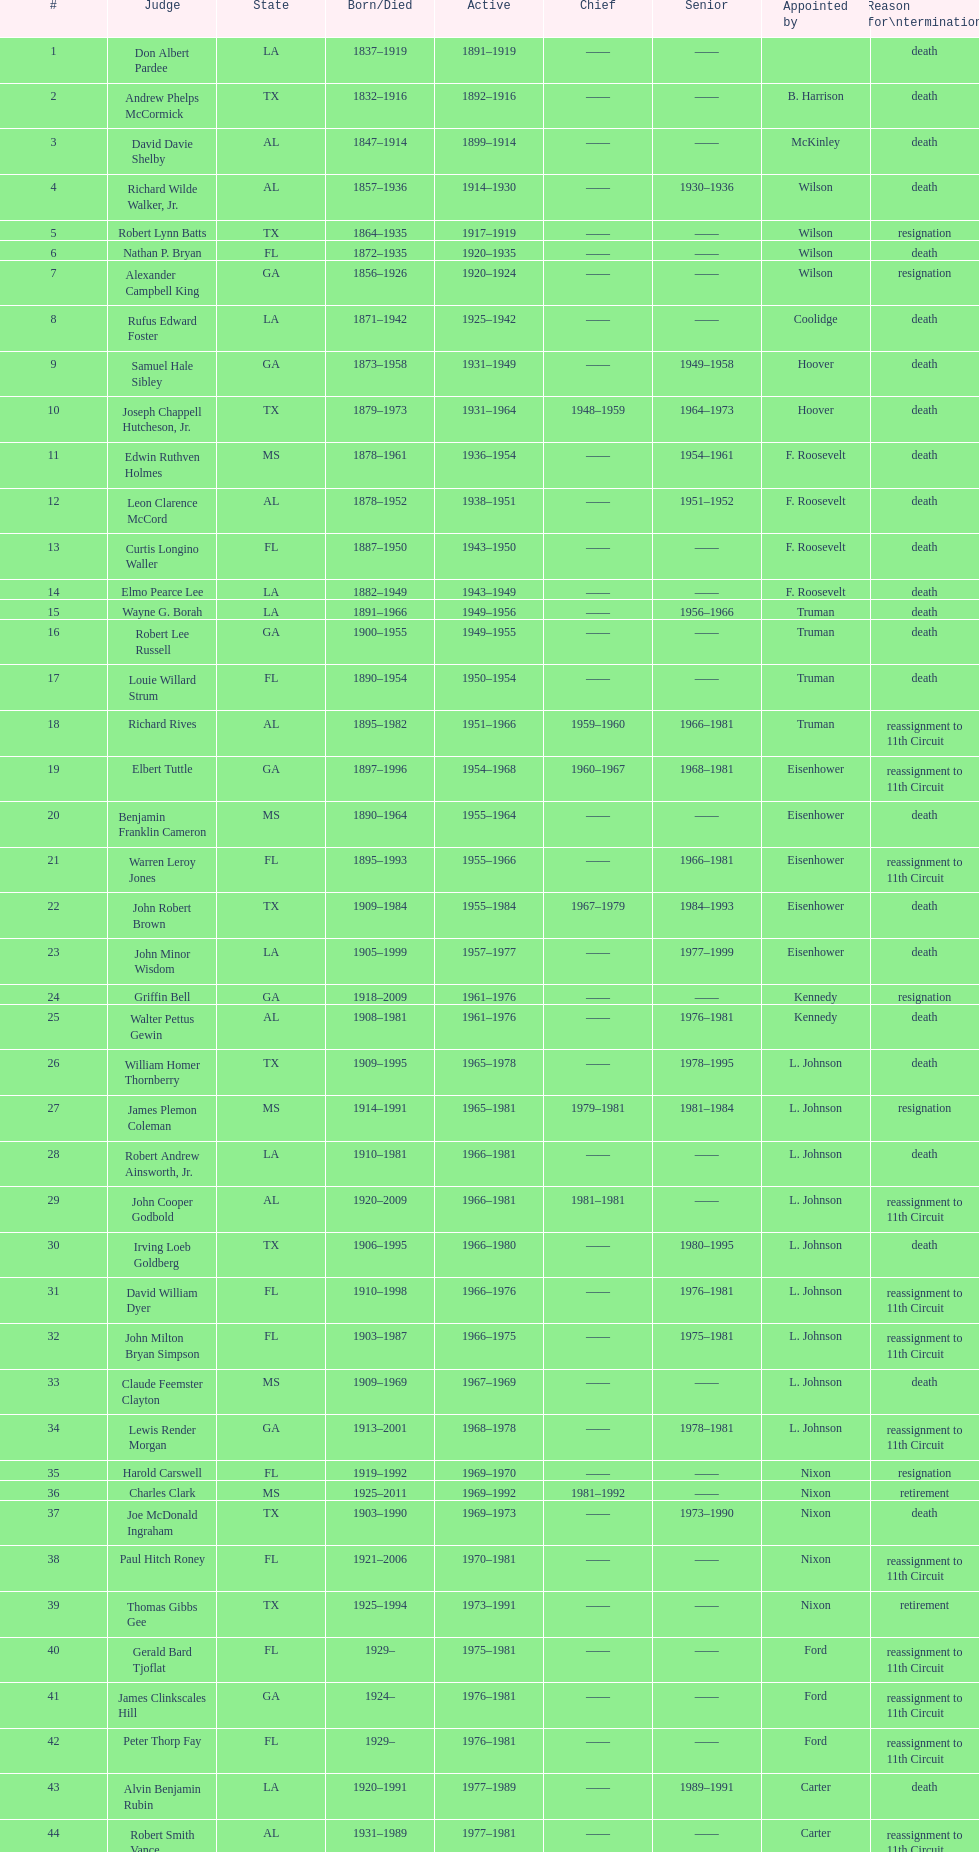How many justices were nominated by president carter? 13. 